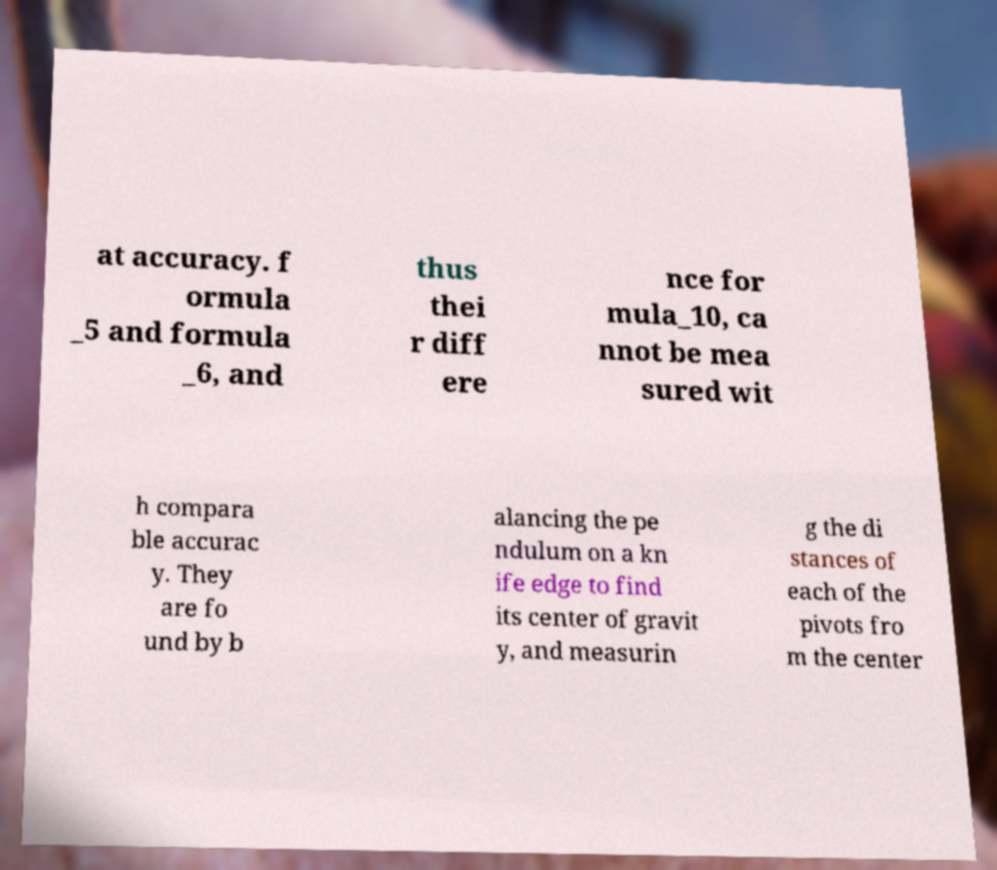Can you read and provide the text displayed in the image?This photo seems to have some interesting text. Can you extract and type it out for me? at accuracy. f ormula _5 and formula _6, and thus thei r diff ere nce for mula_10, ca nnot be mea sured wit h compara ble accurac y. They are fo und by b alancing the pe ndulum on a kn ife edge to find its center of gravit y, and measurin g the di stances of each of the pivots fro m the center 